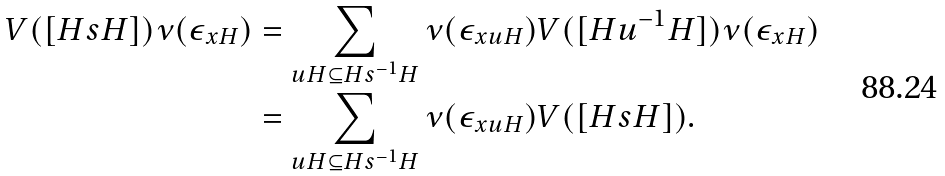Convert formula to latex. <formula><loc_0><loc_0><loc_500><loc_500>V ( [ H s H ] ) \nu ( \epsilon _ { x H } ) & = \sum _ { u H \subseteq H s ^ { - 1 } H } \nu ( \epsilon _ { x u H } ) V ( [ H u ^ { - 1 } H ] ) \nu ( \epsilon _ { x H } ) \\ & = \sum _ { u H \subseteq H s ^ { - 1 } H } \nu ( \epsilon _ { x u H } ) V ( [ H s H ] ) .</formula> 